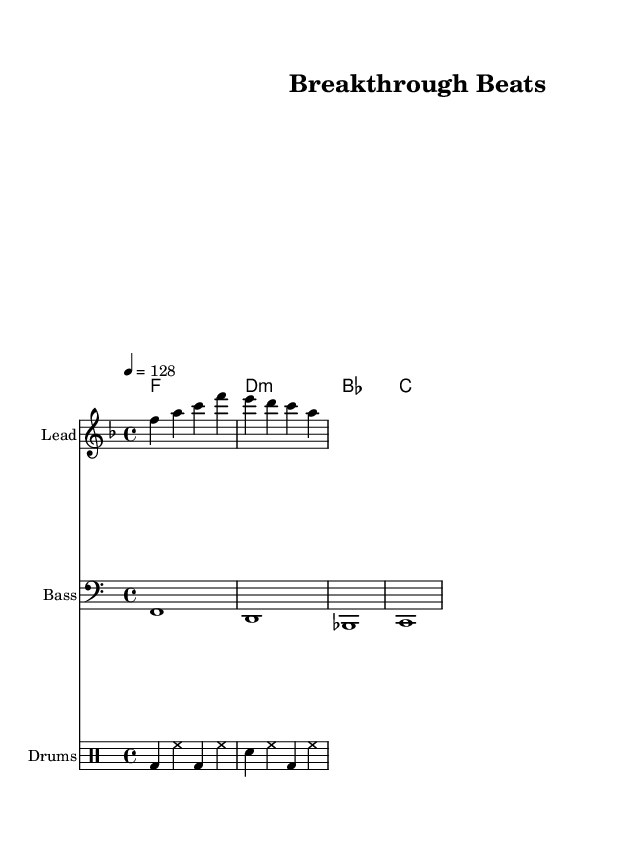What is the key signature of this music? The key signature is identified by the two flats in the beginning of the staff, which indicates F major.
Answer: F major What is the time signature of this music? The time signature is found at the beginning of the score and indicates how many beats are in each measure, which is shown as 4/4.
Answer: 4/4 What is the tempo marking of this music? The tempo marking, located above the staff, indicates how fast the music should be played, specified as a quarter note equals 128 beats per minute.
Answer: 128 How many measures are in the melody section? Counting each distinct vertical line on the staff, each measure is separated by bar lines. There are four measures in the melody section.
Answer: 4 What type of chords are used in the harmonies section? The harmonies section specifies the chords as F major, D minor, B flat major, and C major, which are all basic triads typically found in house music.
Answer: Major and minor triads What is the kick drum pattern in the drum section? Analyzing the drum pattern written in the drummode, the kick drum plays on the first and third beats of each measure, following a repeated sequence in the provided measures.
Answer: BD on the first and third beats What is the clef used in the bass staff? The clef for the bass staff is notated at the beginning of that staff, which is the bass clef indicating that it is for lower pitches.
Answer: Bass clef 